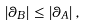Convert formula to latex. <formula><loc_0><loc_0><loc_500><loc_500>\left | \theta _ { B } \right | \leq \left | \theta _ { A } \right | ,</formula> 